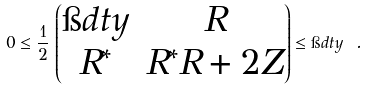<formula> <loc_0><loc_0><loc_500><loc_500>0 \leq { \frac { 1 } { 2 } } \, \begin{pmatrix} \i d t y & R \\ R ^ { * } & R ^ { * } R + 2 Z \end{pmatrix} \leq \i d t y \ .</formula> 